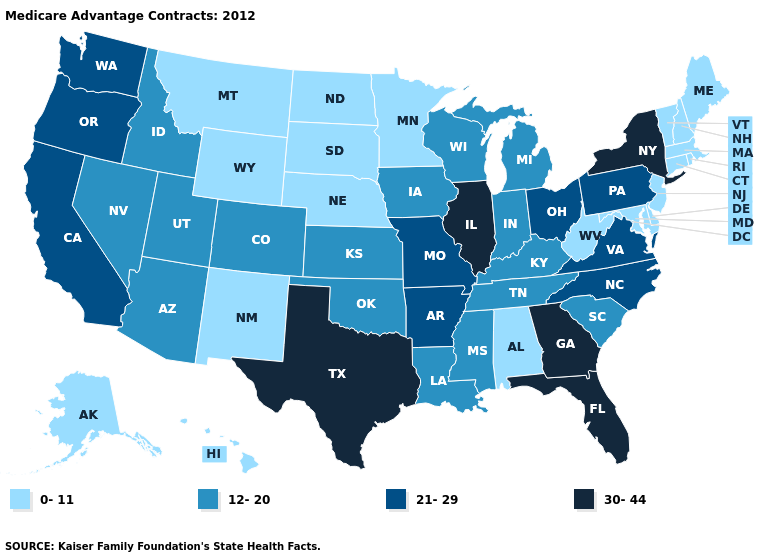Does Kansas have a lower value than Indiana?
Answer briefly. No. Does Kansas have the same value as Iowa?
Give a very brief answer. Yes. Among the states that border Iowa , does South Dakota have the highest value?
Short answer required. No. Does Oregon have a lower value than Texas?
Give a very brief answer. Yes. How many symbols are there in the legend?
Concise answer only. 4. Name the states that have a value in the range 0-11?
Be succinct. Alaska, Alabama, Connecticut, Delaware, Hawaii, Massachusetts, Maryland, Maine, Minnesota, Montana, North Dakota, Nebraska, New Hampshire, New Jersey, New Mexico, Rhode Island, South Dakota, Vermont, West Virginia, Wyoming. Among the states that border New York , which have the lowest value?
Be succinct. Connecticut, Massachusetts, New Jersey, Vermont. What is the value of Maryland?
Keep it brief. 0-11. Does North Carolina have a higher value than New Hampshire?
Quick response, please. Yes. What is the value of Alabama?
Concise answer only. 0-11. Name the states that have a value in the range 0-11?
Be succinct. Alaska, Alabama, Connecticut, Delaware, Hawaii, Massachusetts, Maryland, Maine, Minnesota, Montana, North Dakota, Nebraska, New Hampshire, New Jersey, New Mexico, Rhode Island, South Dakota, Vermont, West Virginia, Wyoming. Name the states that have a value in the range 30-44?
Be succinct. Florida, Georgia, Illinois, New York, Texas. What is the lowest value in states that border South Dakota?
Answer briefly. 0-11. Name the states that have a value in the range 0-11?
Answer briefly. Alaska, Alabama, Connecticut, Delaware, Hawaii, Massachusetts, Maryland, Maine, Minnesota, Montana, North Dakota, Nebraska, New Hampshire, New Jersey, New Mexico, Rhode Island, South Dakota, Vermont, West Virginia, Wyoming. 